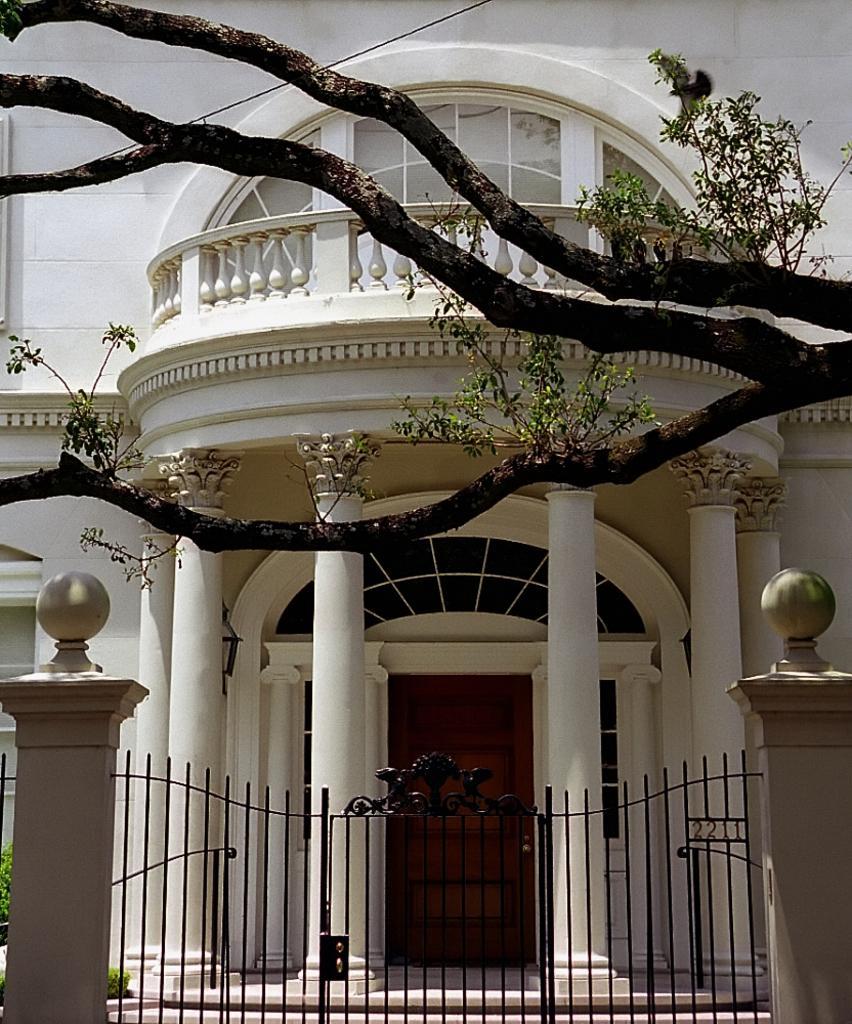Please provide a concise description of this image. In this image in the center there is a building and tree, at the bottom of the image there is gate. And on the right side and left side there are pillars, and in the background there is a door and some pillars and railing. 